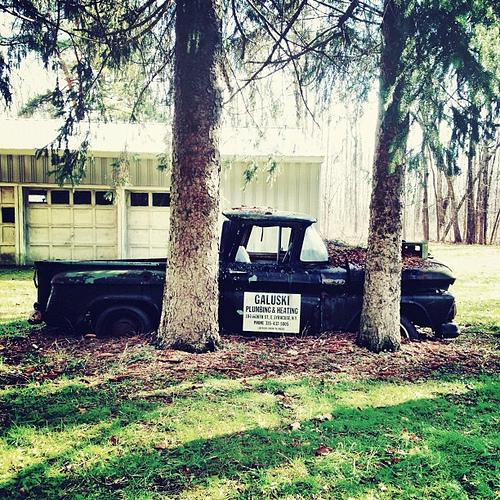Describe the location where the central object is placed in the image. The old truck is situated on a grassy area surrounded by brown leaves, flanked by two trees, and situated in front of a building with white garage doors. Describe the color palette and the interplay of light and shadow in the image. Muted shades of blue, green, brown, and white dominate the image, as sunlight filters through the trees, casting a mixture of shadow and sunshine on the grass surrounding the old truck. Narrate a scene that incorporates the various components present in the image. Amidst a sunny day, an old truck is parked beside two trees, their leaves scattered on the ground, while sunlight filters through the foliage, casting shadows onto the grass. Mention the most significant objects in the image and the setting in which they are found. An old truck, two trees, scattered leaves, and white garage doors form the composition of this peaceful scene set in a sunlit, grassy area. Write a sentence centered on the most notable feature evident in the image. An old pick-up truck, surrounded by brown leaves and green grass, stands behind two trees, its tires partially sunk into the ground. Provide a detailed description of the primary object in the photograph. An old truck is parked in the grass, with its tires partially sunk into the ground, leaves on top of it, and a white sign with black lettering on its side. Mention the key elements in the image and their relation to the main subject. An old truck is parked beside two trees with green and brown leaves scattered on the ground, while white garage doors and a building can be seen in the background. Create a brief visual description focusing on the environment around the main subject of the image. A serene scene unfolds as an old truck rests on a grassy area sprinkled with brown leaves, flanked by trees, and backdropped with a building featuring white garage doors. Write a sentence that captures the overall atmosphere of the image. An air of tranquility pervades this scene, with an old truck parked among the brown leaves and green grass, in between two trees, and near a building with white garage doors. Using vivid adjectives, describe the most prominent object and its surroundings in the image. A weathered, blue truck is parked on a grassy patch covered in brown leaves, nestled between two lush trees with green foliage, and situated near a building with white garage doors. 